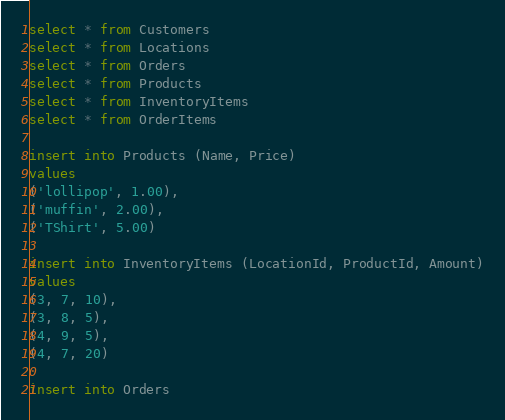<code> <loc_0><loc_0><loc_500><loc_500><_SQL_>select * from Customers
select * from Locations
select * from Orders
select * from Products
select * from InventoryItems
select * from OrderItems

insert into Products (Name, Price)
values
('lollipop', 1.00),
('muffin', 2.00),
('TShirt', 5.00)

insert into InventoryItems (LocationId, ProductId, Amount)
values
(3, 7, 10),
(3, 8, 5),
(4, 9, 5),
(4, 7, 20)

insert into Orders</code> 